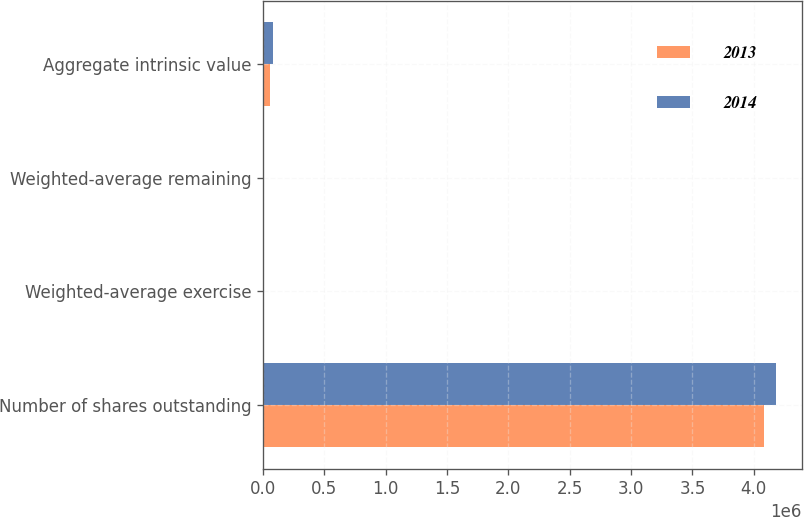Convert chart. <chart><loc_0><loc_0><loc_500><loc_500><stacked_bar_chart><ecel><fcel>Number of shares outstanding<fcel>Weighted-average exercise<fcel>Weighted-average remaining<fcel>Aggregate intrinsic value<nl><fcel>2013<fcel>4.07991e+06<fcel>40.69<fcel>5.85<fcel>54989<nl><fcel>2014<fcel>4.18365e+06<fcel>32.98<fcel>5.81<fcel>80002<nl></chart> 